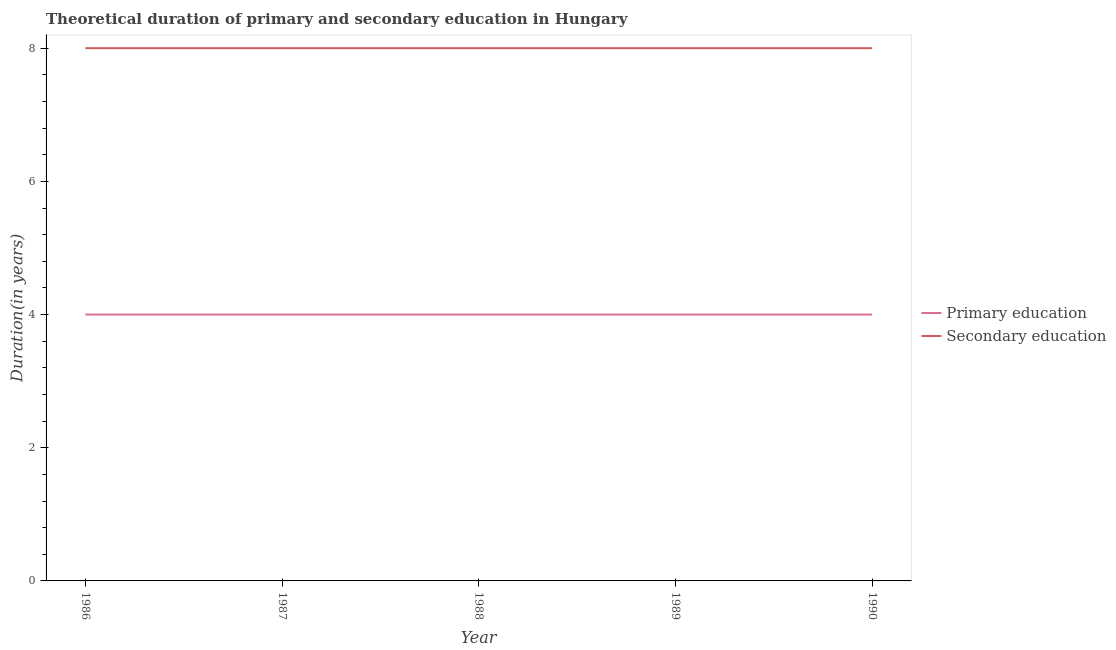Is the number of lines equal to the number of legend labels?
Your answer should be very brief. Yes. What is the duration of secondary education in 1986?
Ensure brevity in your answer.  8. Across all years, what is the maximum duration of primary education?
Make the answer very short. 4. Across all years, what is the minimum duration of primary education?
Your answer should be very brief. 4. In which year was the duration of secondary education minimum?
Offer a terse response. 1986. What is the total duration of primary education in the graph?
Offer a very short reply. 20. What is the difference between the duration of secondary education in 1988 and the duration of primary education in 1987?
Give a very brief answer. 4. In the year 1989, what is the difference between the duration of primary education and duration of secondary education?
Your response must be concise. -4. In how many years, is the duration of primary education greater than 7.6 years?
Your answer should be compact. 0. What is the ratio of the duration of primary education in 1988 to that in 1990?
Your answer should be compact. 1. What is the difference between the highest and the lowest duration of primary education?
Provide a succinct answer. 0. Does the duration of primary education monotonically increase over the years?
Your answer should be compact. No. Is the duration of secondary education strictly less than the duration of primary education over the years?
Your answer should be compact. No. What is the difference between two consecutive major ticks on the Y-axis?
Offer a very short reply. 2. Are the values on the major ticks of Y-axis written in scientific E-notation?
Offer a terse response. No. Does the graph contain grids?
Provide a short and direct response. No. How are the legend labels stacked?
Your response must be concise. Vertical. What is the title of the graph?
Your answer should be very brief. Theoretical duration of primary and secondary education in Hungary. Does "Taxes on exports" appear as one of the legend labels in the graph?
Your response must be concise. No. What is the label or title of the X-axis?
Offer a terse response. Year. What is the label or title of the Y-axis?
Your answer should be compact. Duration(in years). What is the Duration(in years) of Secondary education in 1986?
Keep it short and to the point. 8. Across all years, what is the minimum Duration(in years) of Primary education?
Provide a short and direct response. 4. What is the total Duration(in years) of Primary education in the graph?
Give a very brief answer. 20. What is the total Duration(in years) of Secondary education in the graph?
Provide a succinct answer. 40. What is the difference between the Duration(in years) in Primary education in 1986 and that in 1987?
Keep it short and to the point. 0. What is the difference between the Duration(in years) in Secondary education in 1986 and that in 1987?
Keep it short and to the point. 0. What is the difference between the Duration(in years) in Primary education in 1986 and that in 1988?
Provide a succinct answer. 0. What is the difference between the Duration(in years) in Primary education in 1986 and that in 1989?
Your response must be concise. 0. What is the difference between the Duration(in years) in Primary education in 1986 and that in 1990?
Provide a succinct answer. 0. What is the difference between the Duration(in years) of Primary education in 1987 and that in 1989?
Make the answer very short. 0. What is the difference between the Duration(in years) of Secondary education in 1987 and that in 1989?
Provide a short and direct response. 0. What is the difference between the Duration(in years) in Primary education in 1987 and that in 1990?
Your response must be concise. 0. What is the difference between the Duration(in years) in Secondary education in 1987 and that in 1990?
Ensure brevity in your answer.  0. What is the difference between the Duration(in years) in Primary education in 1988 and that in 1990?
Make the answer very short. 0. What is the difference between the Duration(in years) in Secondary education in 1988 and that in 1990?
Offer a terse response. 0. What is the difference between the Duration(in years) of Secondary education in 1989 and that in 1990?
Make the answer very short. 0. What is the difference between the Duration(in years) of Primary education in 1986 and the Duration(in years) of Secondary education in 1987?
Give a very brief answer. -4. What is the difference between the Duration(in years) of Primary education in 1986 and the Duration(in years) of Secondary education in 1988?
Your answer should be compact. -4. What is the difference between the Duration(in years) of Primary education in 1986 and the Duration(in years) of Secondary education in 1989?
Your response must be concise. -4. What is the difference between the Duration(in years) of Primary education in 1986 and the Duration(in years) of Secondary education in 1990?
Your response must be concise. -4. What is the difference between the Duration(in years) in Primary education in 1987 and the Duration(in years) in Secondary education in 1988?
Your answer should be very brief. -4. What is the difference between the Duration(in years) of Primary education in 1988 and the Duration(in years) of Secondary education in 1989?
Make the answer very short. -4. What is the difference between the Duration(in years) in Primary education in 1988 and the Duration(in years) in Secondary education in 1990?
Your answer should be very brief. -4. What is the average Duration(in years) in Primary education per year?
Your response must be concise. 4. In the year 1986, what is the difference between the Duration(in years) of Primary education and Duration(in years) of Secondary education?
Provide a short and direct response. -4. In the year 1987, what is the difference between the Duration(in years) in Primary education and Duration(in years) in Secondary education?
Give a very brief answer. -4. In the year 1988, what is the difference between the Duration(in years) in Primary education and Duration(in years) in Secondary education?
Provide a succinct answer. -4. In the year 1990, what is the difference between the Duration(in years) in Primary education and Duration(in years) in Secondary education?
Ensure brevity in your answer.  -4. What is the ratio of the Duration(in years) of Primary education in 1986 to that in 1988?
Keep it short and to the point. 1. What is the ratio of the Duration(in years) of Primary education in 1986 to that in 1989?
Offer a terse response. 1. What is the ratio of the Duration(in years) in Secondary education in 1986 to that in 1989?
Your response must be concise. 1. What is the ratio of the Duration(in years) of Primary education in 1986 to that in 1990?
Your answer should be compact. 1. What is the ratio of the Duration(in years) of Secondary education in 1986 to that in 1990?
Your answer should be very brief. 1. What is the ratio of the Duration(in years) of Primary education in 1987 to that in 1988?
Provide a short and direct response. 1. What is the ratio of the Duration(in years) in Secondary education in 1987 to that in 1988?
Offer a terse response. 1. What is the ratio of the Duration(in years) in Primary education in 1987 to that in 1989?
Keep it short and to the point. 1. What is the ratio of the Duration(in years) of Primary education in 1988 to that in 1989?
Offer a terse response. 1. What is the ratio of the Duration(in years) in Secondary education in 1988 to that in 1989?
Offer a terse response. 1. What is the ratio of the Duration(in years) in Primary education in 1988 to that in 1990?
Your response must be concise. 1. What is the ratio of the Duration(in years) in Secondary education in 1989 to that in 1990?
Make the answer very short. 1. What is the difference between the highest and the second highest Duration(in years) in Secondary education?
Provide a succinct answer. 0. What is the difference between the highest and the lowest Duration(in years) of Secondary education?
Your answer should be very brief. 0. 